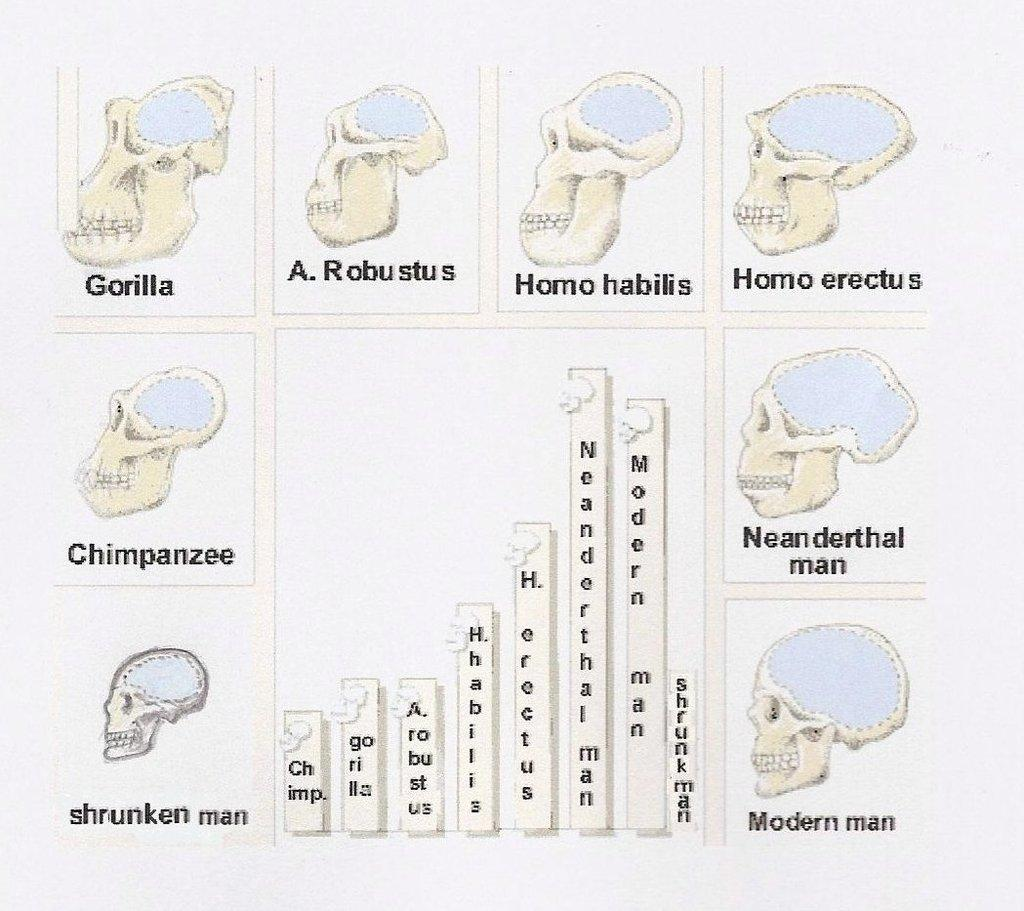What type of diagrams are present in the image? There are diagrams of a skull in the image. What other type of visual representation can be seen in the image? There is a graph in the center of the image. What type of star is depicted in the image? There is no star present in the image; it contains diagrams of a skull and a graph. What type of furniture can be seen in the image? There is no furniture present in the image; it contains diagrams of a skull and a graph. 